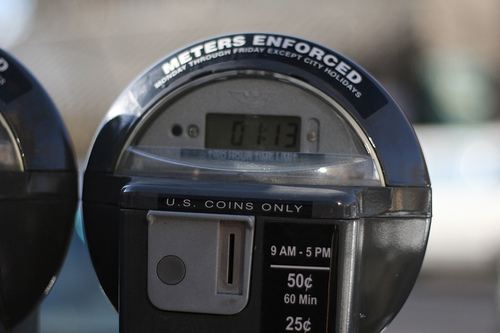Identify the text contained in this image. METERS 01 : 13 U. S. COINS ONLY 25 Min 60 50 PM 5 AM 9 HOLIDAYS CITY FRIDAY ML ENFORCED 